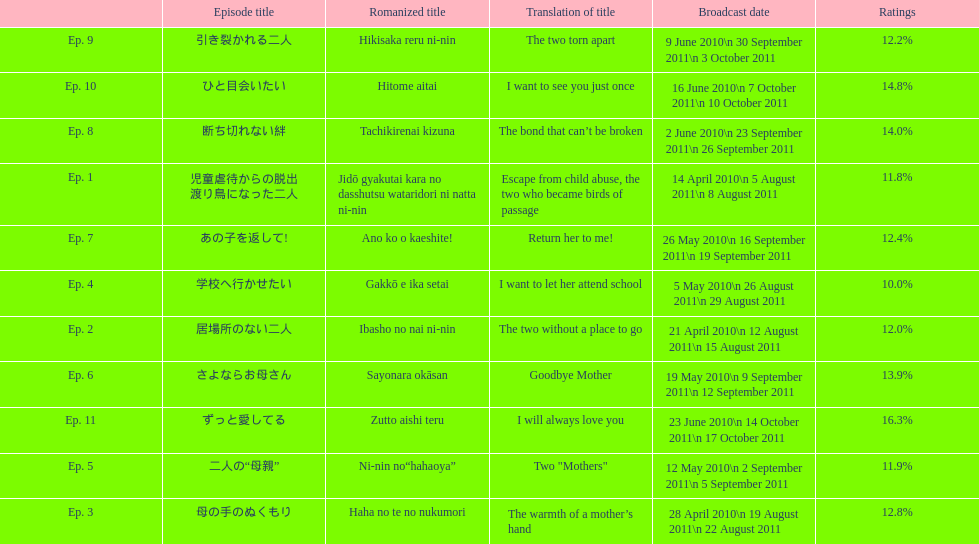What was the name of the first episode of this show? 児童虐待からの脱出 渡り鳥になった二人. 